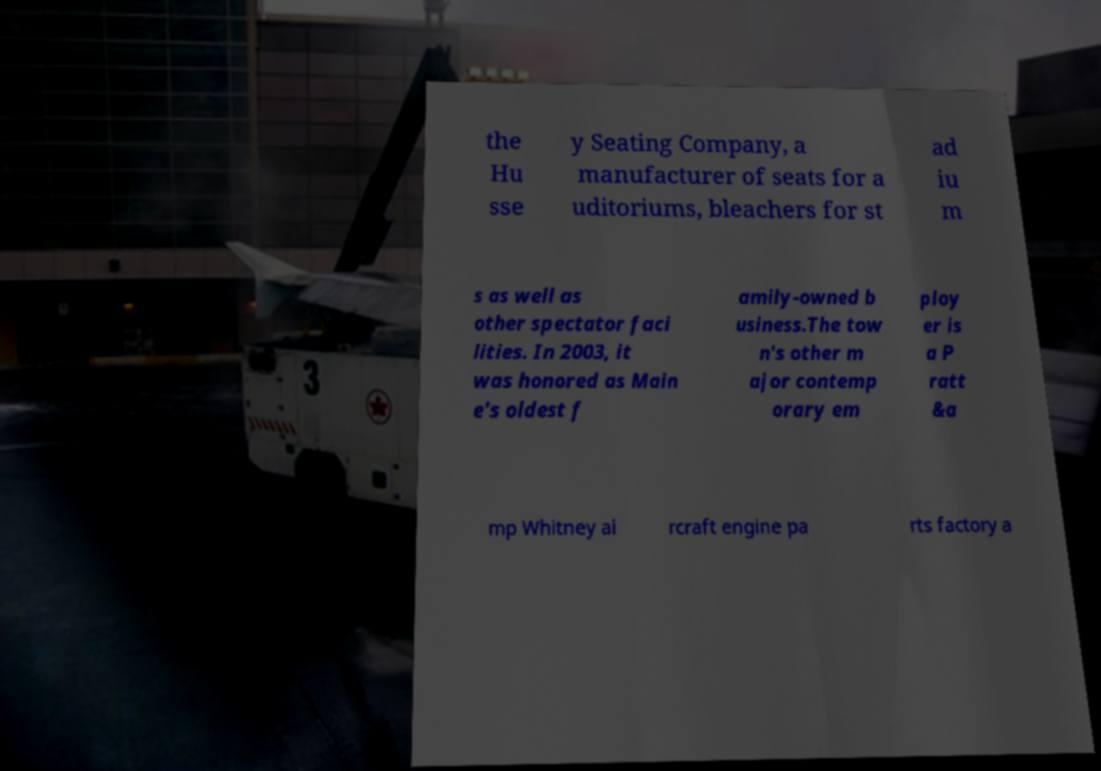For documentation purposes, I need the text within this image transcribed. Could you provide that? the Hu sse y Seating Company, a manufacturer of seats for a uditoriums, bleachers for st ad iu m s as well as other spectator faci lities. In 2003, it was honored as Main e's oldest f amily-owned b usiness.The tow n's other m ajor contemp orary em ploy er is a P ratt &a mp Whitney ai rcraft engine pa rts factory a 